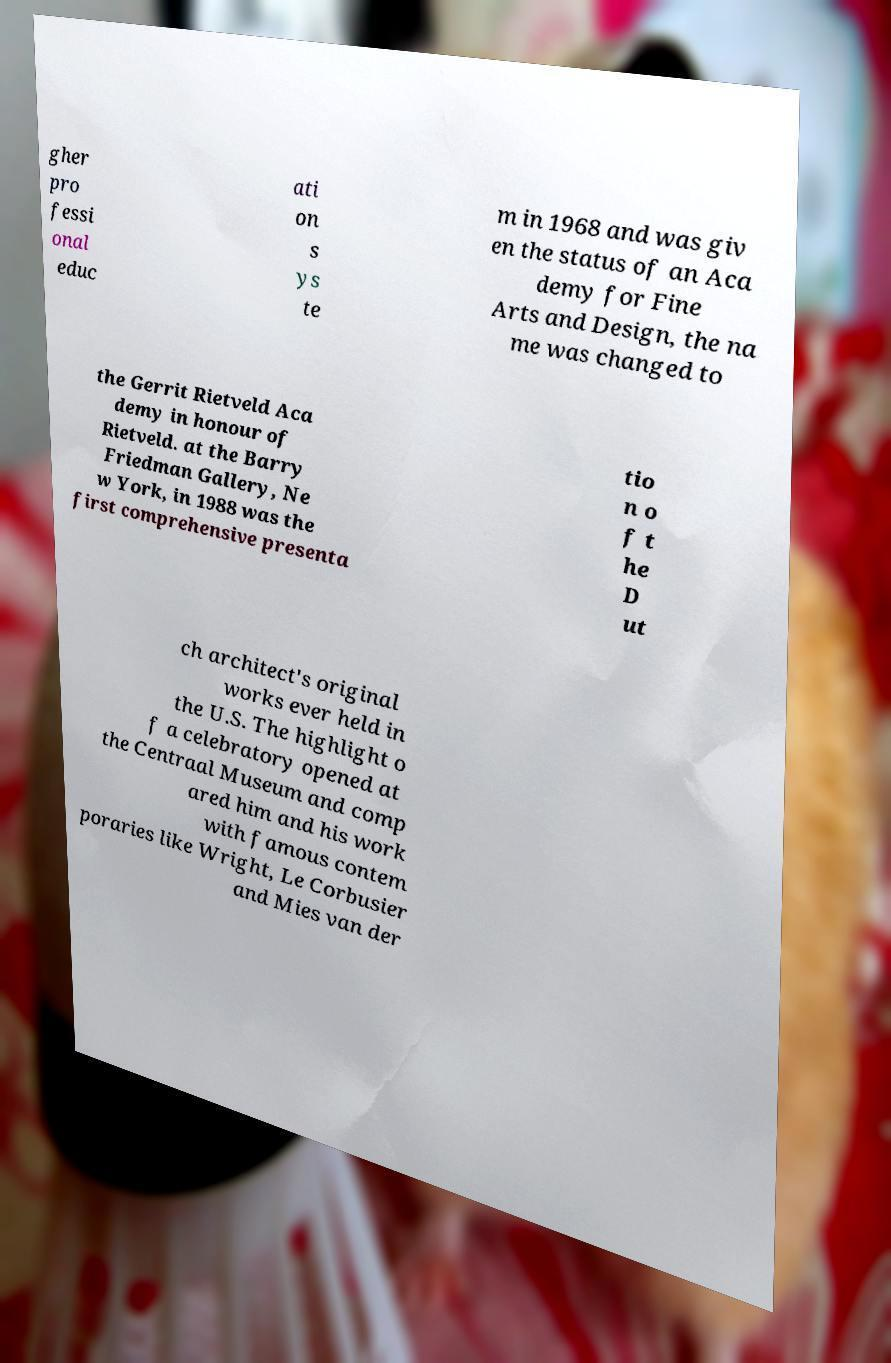Can you accurately transcribe the text from the provided image for me? gher pro fessi onal educ ati on s ys te m in 1968 and was giv en the status of an Aca demy for Fine Arts and Design, the na me was changed to the Gerrit Rietveld Aca demy in honour of Rietveld. at the Barry Friedman Gallery, Ne w York, in 1988 was the first comprehensive presenta tio n o f t he D ut ch architect's original works ever held in the U.S. The highlight o f a celebratory opened at the Centraal Museum and comp ared him and his work with famous contem poraries like Wright, Le Corbusier and Mies van der 